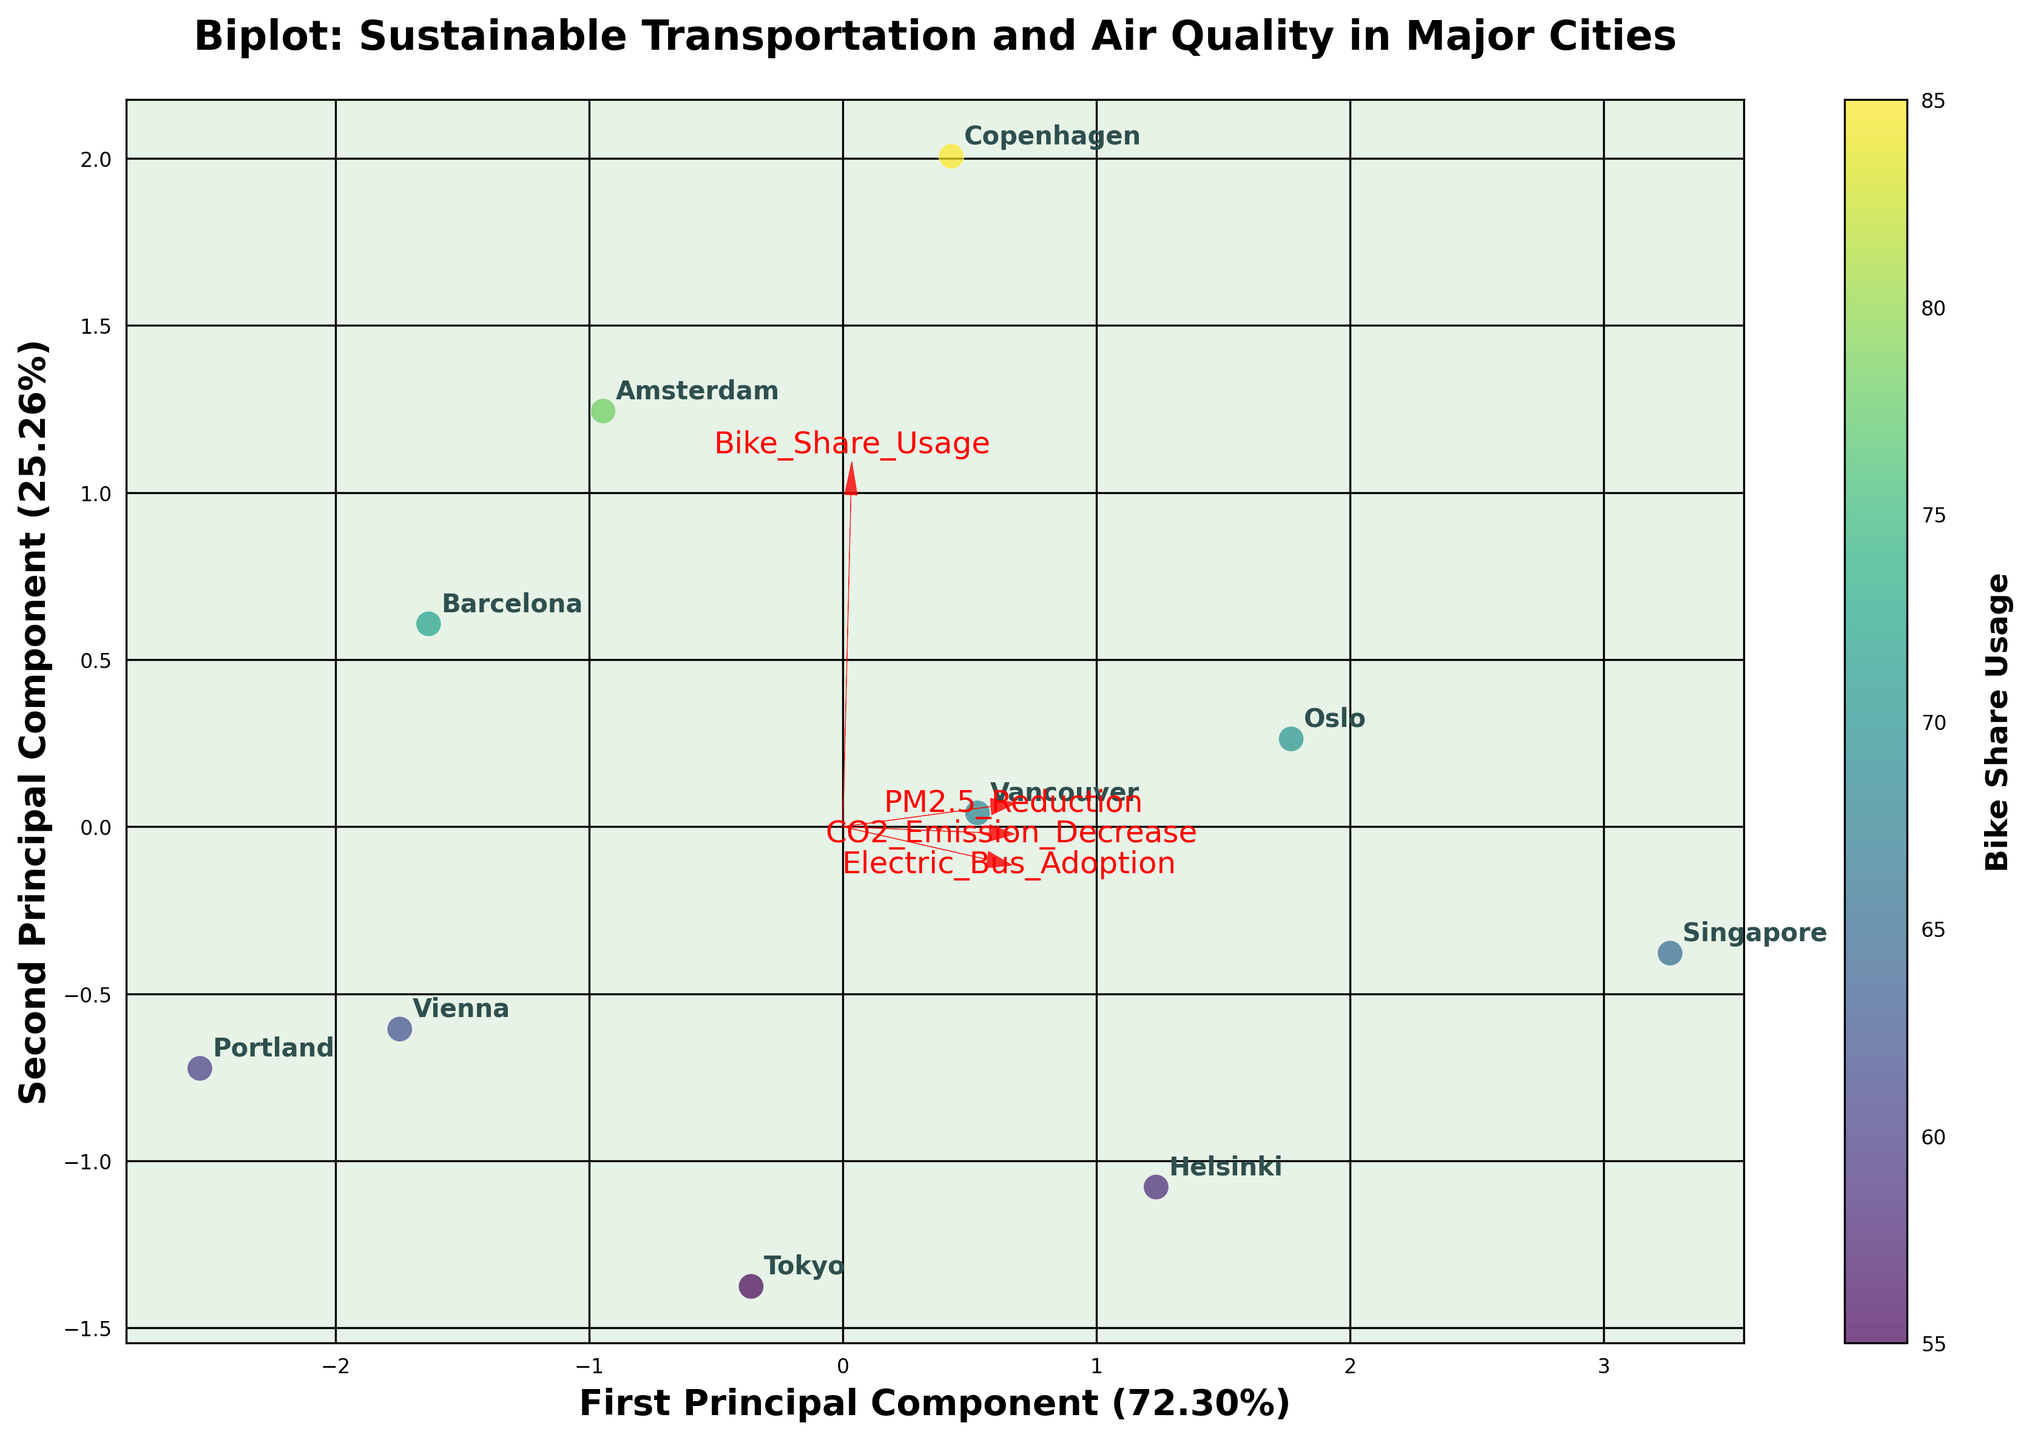How many cities are included in the biplot? By looking at the number of data points labeled with city names in the scatter plot, we can count how many are present.
Answer: 10 What is the title of the biplot? The title is located at the top of the plot and reads as a descriptor of the data shown.
Answer: Biplot: Sustainable Transportation and Air Quality in Major Cities Which city is associated with the highest Bike Share Usage and what is its corresponding position on the biplot? We need to look at the color gradient on the scatter plot legend for 'Bike Share Usage' and identify the city at the highest end. Then locate this city on the plot.
Answer: Copenhagen; near the top-right What are the labels of the axes in the biplot? The x-axis and y-axis labels, which explain what the principal components represent, are indicated by titles at the respective ends of the axes.
Answer: First Principal Component (xx.x%) and Second Principal Component (xx.x%) Which two cities appear closest to each other in the biplot? By observing the positions of the data points, we should check which pair is situated nearest to each other spatially.
Answer: Amsterdam and Vienna Which feature vectors have the steepest angle from the first principal component? By observing the angles of the red arrows from the x-axis (First Principal Component), identify the vectors that deviate most visibly.
Answer: PM2.5 Reduction and CO2 Emission Decrease How does Oslo's position on the second principal component compare to Singapore's? Check the vertical positions (y-axis) for both cities' data points to see which one is higher or lower.
Answer: Oslo is lower than Singapore What is the feature most aligned with the first principal component? Identify which red feature vector/arrow extends the furthest along the x-axis (First Principal Component).
Answer: Bike Share Usage Which city shows a high adoption of Electric Buses and also a significant reduction in CO2 emissions? Look at the cities towards the positive side of the Electric Bus Adoption vector and cross-reference with their position relative to the CO2 Emission Decrease vector.
Answer: Singapore Which component explains the larger percentage of the variance in the data? The labels on the x-axis and y-axis indicate the explained variance in percentages for each component, compare these values.
Answer: First Principal Component 